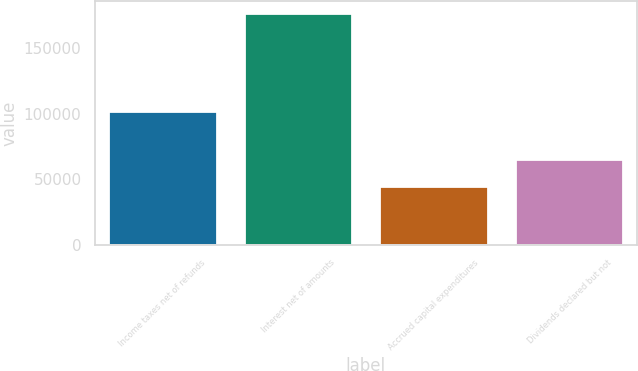Convert chart. <chart><loc_0><loc_0><loc_500><loc_500><bar_chart><fcel>Income taxes net of refunds<fcel>Interest net of amounts<fcel>Accrued capital expenditures<fcel>Dividends declared but not<nl><fcel>102154<fcel>177074<fcel>44712<fcel>65790<nl></chart> 